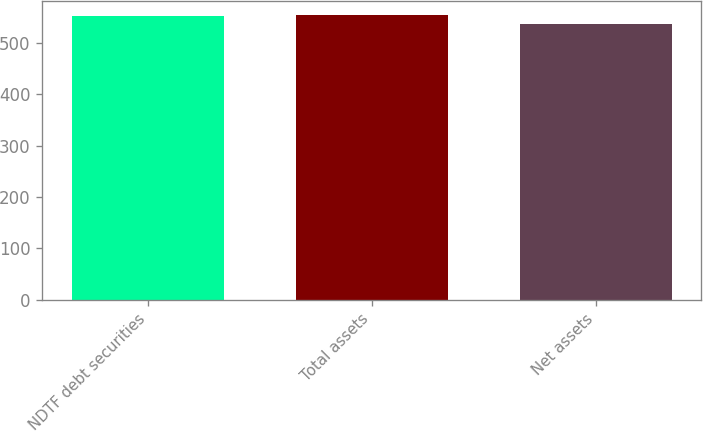Convert chart to OTSL. <chart><loc_0><loc_0><loc_500><loc_500><bar_chart><fcel>NDTF debt securities<fcel>Total assets<fcel>Net assets<nl><fcel>553<fcel>554.7<fcel>537<nl></chart> 